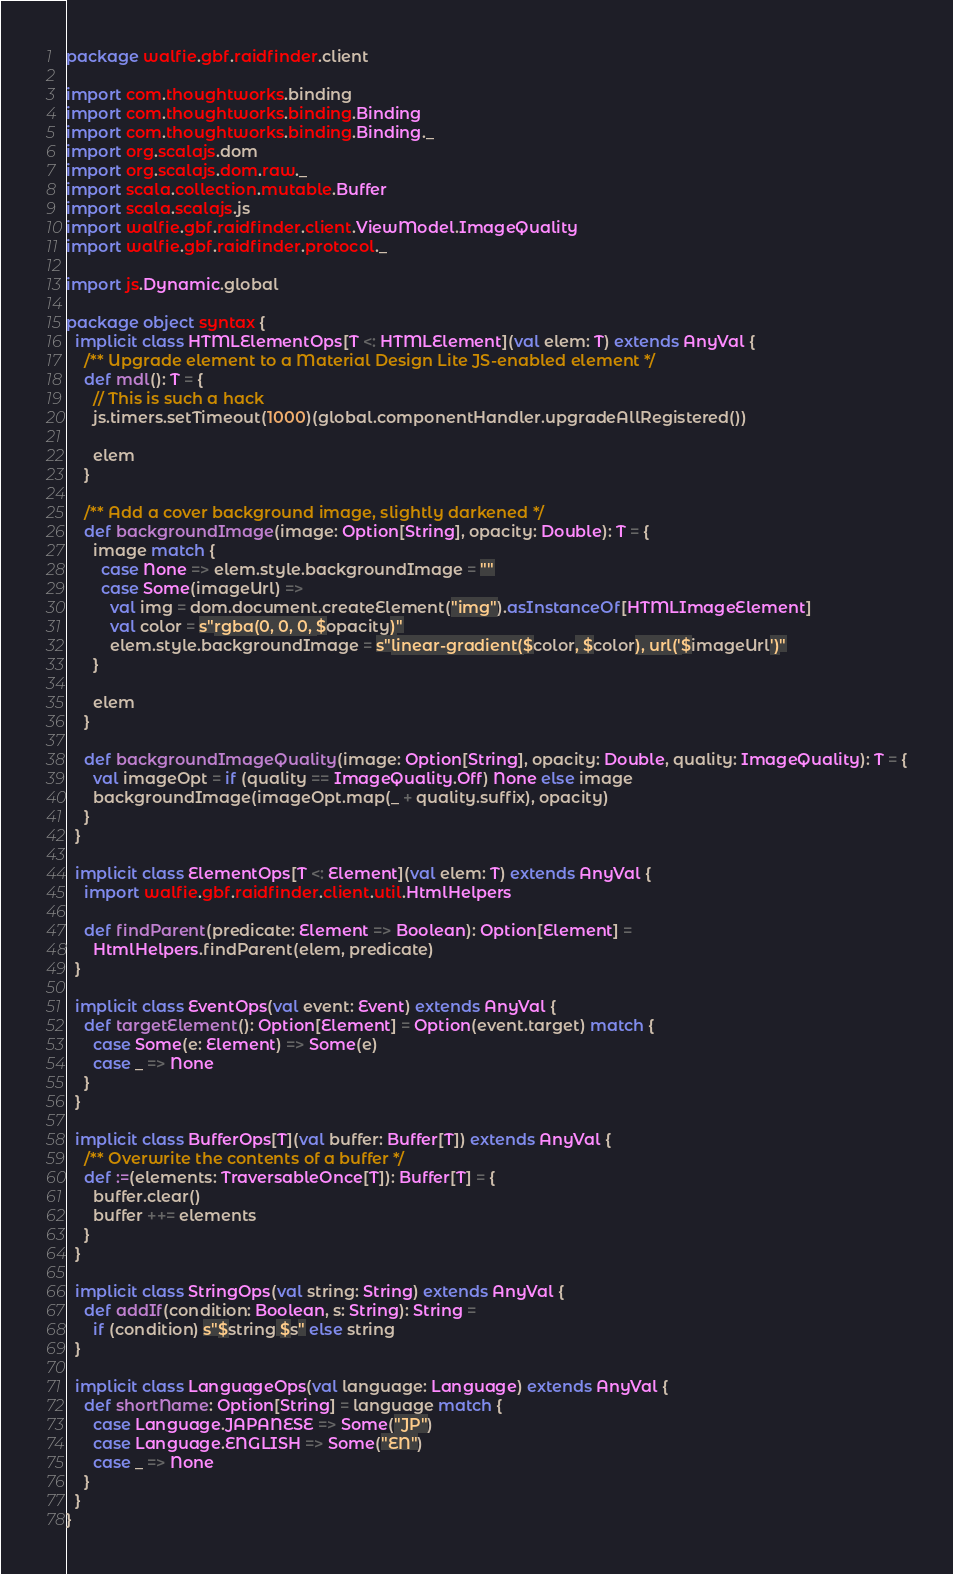<code> <loc_0><loc_0><loc_500><loc_500><_Scala_>package walfie.gbf.raidfinder.client

import com.thoughtworks.binding
import com.thoughtworks.binding.Binding
import com.thoughtworks.binding.Binding._
import org.scalajs.dom
import org.scalajs.dom.raw._
import scala.collection.mutable.Buffer
import scala.scalajs.js
import walfie.gbf.raidfinder.client.ViewModel.ImageQuality
import walfie.gbf.raidfinder.protocol._

import js.Dynamic.global

package object syntax {
  implicit class HTMLElementOps[T <: HTMLElement](val elem: T) extends AnyVal {
    /** Upgrade element to a Material Design Lite JS-enabled element */
    def mdl(): T = {
      // This is such a hack
      js.timers.setTimeout(1000)(global.componentHandler.upgradeAllRegistered())

      elem
    }

    /** Add a cover background image, slightly darkened */
    def backgroundImage(image: Option[String], opacity: Double): T = {
      image match {
        case None => elem.style.backgroundImage = ""
        case Some(imageUrl) =>
          val img = dom.document.createElement("img").asInstanceOf[HTMLImageElement]
          val color = s"rgba(0, 0, 0, $opacity)"
          elem.style.backgroundImage = s"linear-gradient($color, $color), url('$imageUrl')"
      }

      elem
    }

    def backgroundImageQuality(image: Option[String], opacity: Double, quality: ImageQuality): T = {
      val imageOpt = if (quality == ImageQuality.Off) None else image
      backgroundImage(imageOpt.map(_ + quality.suffix), opacity)
    }
  }

  implicit class ElementOps[T <: Element](val elem: T) extends AnyVal {
    import walfie.gbf.raidfinder.client.util.HtmlHelpers

    def findParent(predicate: Element => Boolean): Option[Element] =
      HtmlHelpers.findParent(elem, predicate)
  }

  implicit class EventOps(val event: Event) extends AnyVal {
    def targetElement(): Option[Element] = Option(event.target) match {
      case Some(e: Element) => Some(e)
      case _ => None
    }
  }

  implicit class BufferOps[T](val buffer: Buffer[T]) extends AnyVal {
    /** Overwrite the contents of a buffer */
    def :=(elements: TraversableOnce[T]): Buffer[T] = {
      buffer.clear()
      buffer ++= elements
    }
  }

  implicit class StringOps(val string: String) extends AnyVal {
    def addIf(condition: Boolean, s: String): String =
      if (condition) s"$string $s" else string
  }

  implicit class LanguageOps(val language: Language) extends AnyVal {
    def shortName: Option[String] = language match {
      case Language.JAPANESE => Some("JP")
      case Language.ENGLISH => Some("EN")
      case _ => None
    }
  }
}

</code> 